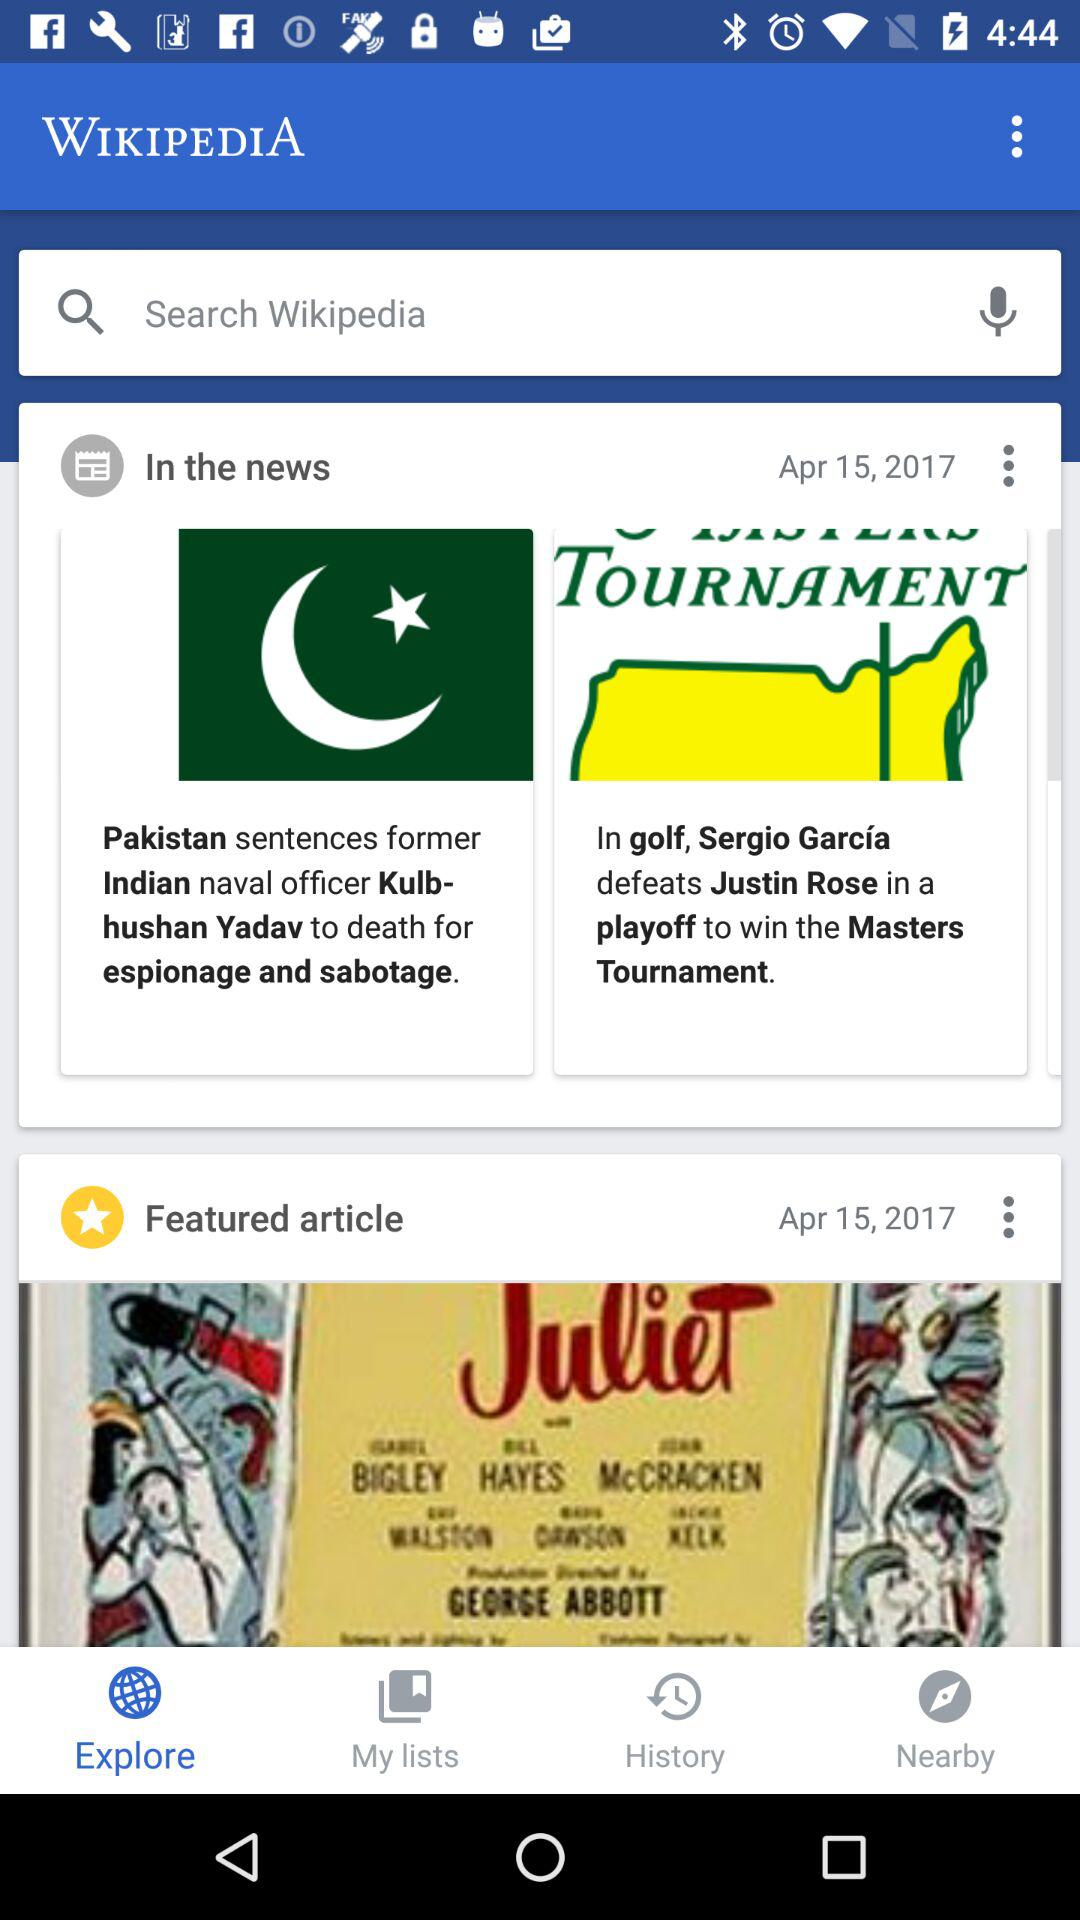What is the publication date of the featured article? The publication date of the featured article is April 15, 2017. 